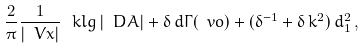<formula> <loc_0><loc_0><loc_500><loc_500>\frac { 2 } { \pi } \frac { 1 } { | \ V { x } | } \, \ k l g \, | \ D A | + \delta \, d \Gamma ( \ v o ) + ( \delta ^ { - 1 } + \delta \, k ^ { 2 } ) \, d _ { 1 } ^ { 2 } \, ,</formula> 